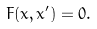Convert formula to latex. <formula><loc_0><loc_0><loc_500><loc_500>F ( x , x ^ { \prime } ) = 0 .</formula> 